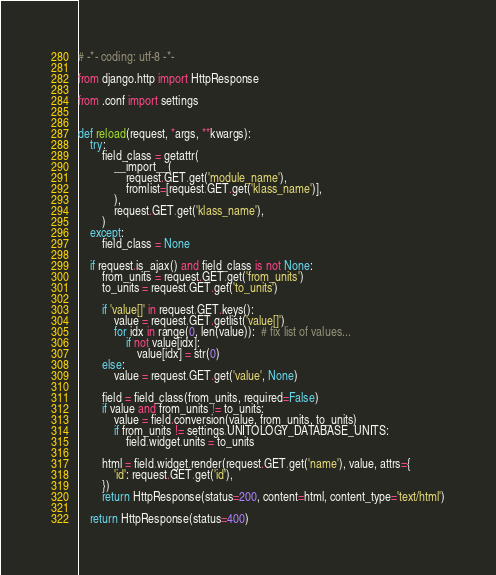<code> <loc_0><loc_0><loc_500><loc_500><_Python_># -*- coding: utf-8 -*-

from django.http import HttpResponse

from .conf import settings


def reload(request, *args, **kwargs):
    try:
        field_class = getattr(
            __import__(
                request.GET.get('module_name'),
                fromlist=[request.GET.get('klass_name')],
            ),
            request.GET.get('klass_name'),
        )
    except:
        field_class = None

    if request.is_ajax() and field_class is not None:
        from_units = request.GET.get('from_units')
        to_units = request.GET.get('to_units')

        if 'value[]' in request.GET.keys():
            value = request.GET.getlist('value[]')
            for idx in range(0, len(value)):  # fix list of values...
                if not value[idx]:
                    value[idx] = str(0)
        else:
            value = request.GET.get('value', None)

        field = field_class(from_units, required=False)
        if value and from_units != to_units:
            value = field.conversion(value, from_units, to_units)
            if from_units != settings.UNITOLOGY_DATABASE_UNITS:
                field.widget.units = to_units

        html = field.widget.render(request.GET.get('name'), value, attrs={
            'id': request.GET.get('id'),
        })
        return HttpResponse(status=200, content=html, content_type='text/html')

    return HttpResponse(status=400)
</code> 